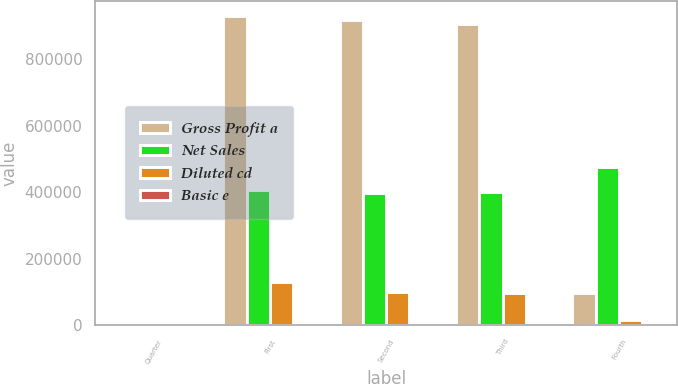<chart> <loc_0><loc_0><loc_500><loc_500><stacked_bar_chart><ecel><fcel>Quarter<fcel>First<fcel>Second<fcel>Third<fcel>Fourth<nl><fcel>Gross Profit a<fcel>2018<fcel>930928<fcel>920016<fcel>907548<fcel>95716<nl><fcel>Net Sales<fcel>2018<fcel>405809<fcel>398717<fcel>400666<fcel>477515<nl><fcel>Diluted cd<fcel>2018<fcel>129416<fcel>99149<fcel>95716<fcel>15500<nl><fcel>Basic e<fcel>2018<fcel>1.63<fcel>1.25<fcel>1.18<fcel>0.09<nl></chart> 